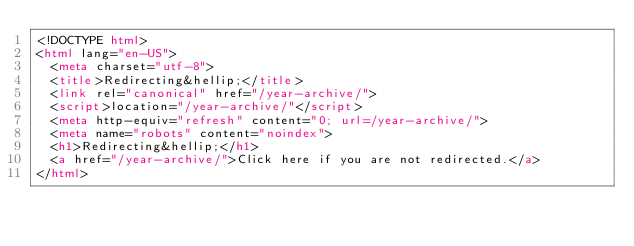Convert code to text. <code><loc_0><loc_0><loc_500><loc_500><_HTML_><!DOCTYPE html>
<html lang="en-US">
  <meta charset="utf-8">
  <title>Redirecting&hellip;</title>
  <link rel="canonical" href="/year-archive/">
  <script>location="/year-archive/"</script>
  <meta http-equiv="refresh" content="0; url=/year-archive/">
  <meta name="robots" content="noindex">
  <h1>Redirecting&hellip;</h1>
  <a href="/year-archive/">Click here if you are not redirected.</a>
</html>
</code> 